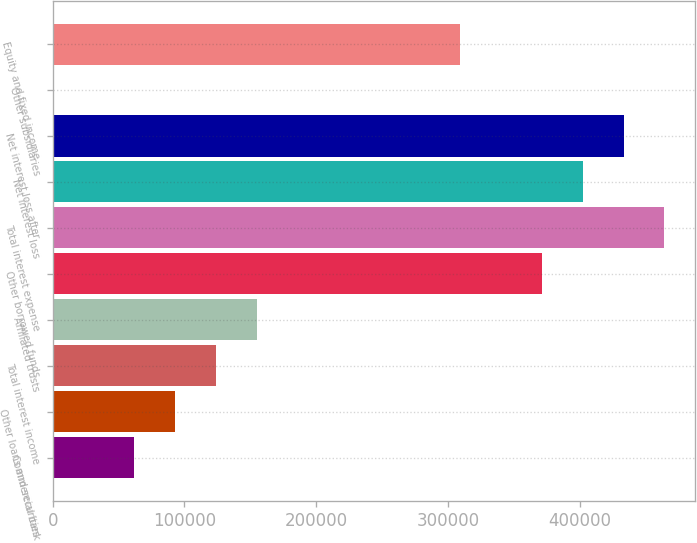Convert chart to OTSL. <chart><loc_0><loc_0><loc_500><loc_500><bar_chart><fcel>Commercial bank<fcel>Other loans and securities<fcel>Total interest income<fcel>Affiliated trusts<fcel>Other borrowed funds<fcel>Total interest expense<fcel>Net interest loss<fcel>Net interest loss after<fcel>Other subsidiaries<fcel>Equity and fixed income<nl><fcel>61974.2<fcel>92911.3<fcel>123848<fcel>154786<fcel>371345<fcel>464156<fcel>402282<fcel>433219<fcel>100<fcel>309471<nl></chart> 